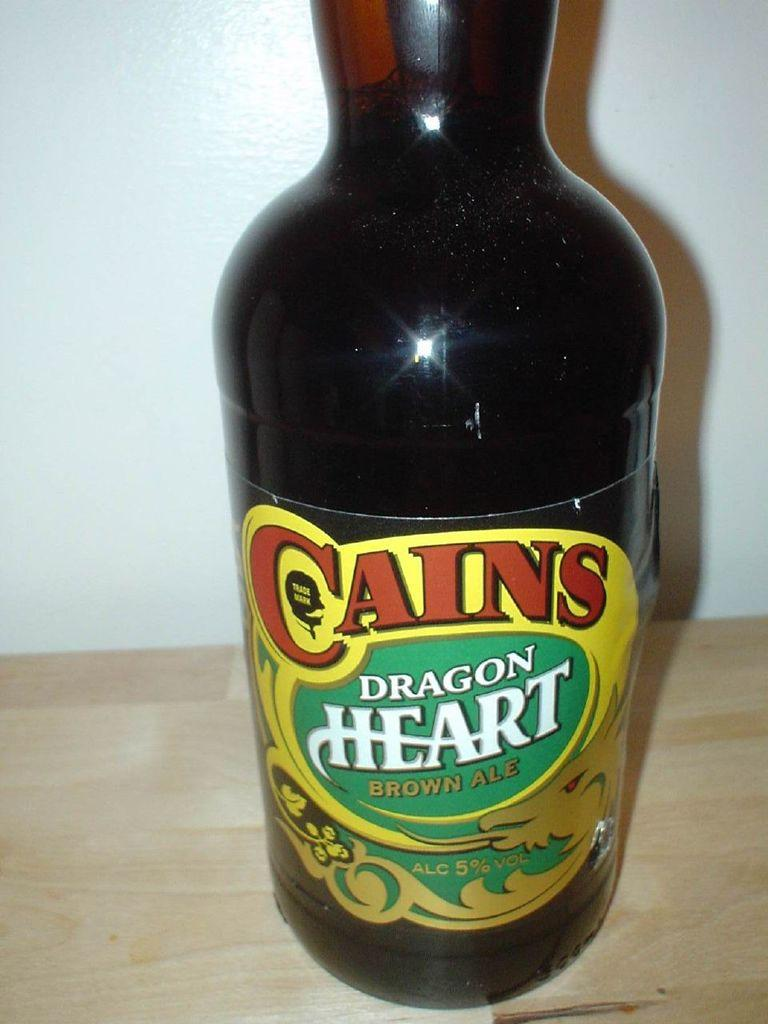What is the main object in the image? There is a bottle with a label in the image. What can be seen on the bottle? The bottle has some text on it. What is the surface that the bottle is placed on? The bottle is placed on a wooden surface. What is visible at the top of the image? There is a wall visible at the top of the image. What is the price of the wool in the image? There is no wool or price mentioned in the image; it only features a bottle with a label on a wooden surface. 